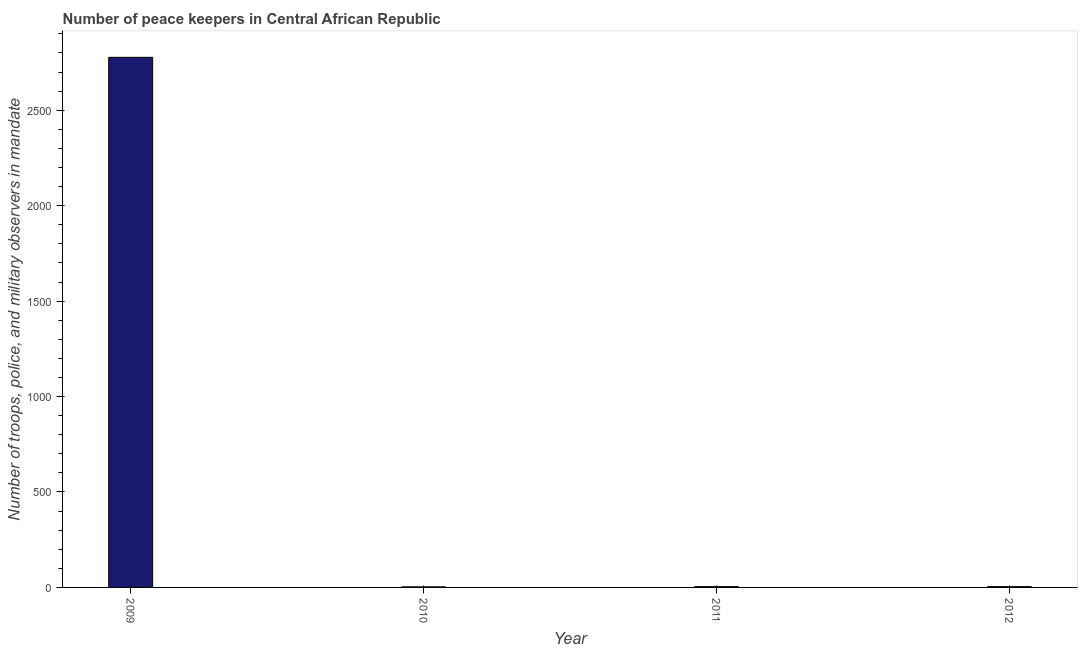Does the graph contain any zero values?
Keep it short and to the point. No. What is the title of the graph?
Offer a very short reply. Number of peace keepers in Central African Republic. What is the label or title of the X-axis?
Your answer should be very brief. Year. What is the label or title of the Y-axis?
Ensure brevity in your answer.  Number of troops, police, and military observers in mandate. What is the number of peace keepers in 2011?
Your response must be concise. 4. Across all years, what is the maximum number of peace keepers?
Offer a very short reply. 2777. In which year was the number of peace keepers minimum?
Provide a succinct answer. 2010. What is the sum of the number of peace keepers?
Provide a succinct answer. 2788. What is the average number of peace keepers per year?
Provide a succinct answer. 697. In how many years, is the number of peace keepers greater than 1600 ?
Your answer should be very brief. 1. What is the ratio of the number of peace keepers in 2010 to that in 2011?
Give a very brief answer. 0.75. Is the number of peace keepers in 2010 less than that in 2012?
Your response must be concise. Yes. Is the difference between the number of peace keepers in 2009 and 2011 greater than the difference between any two years?
Make the answer very short. No. What is the difference between the highest and the second highest number of peace keepers?
Your answer should be compact. 2773. What is the difference between the highest and the lowest number of peace keepers?
Your answer should be very brief. 2774. What is the difference between two consecutive major ticks on the Y-axis?
Your answer should be very brief. 500. Are the values on the major ticks of Y-axis written in scientific E-notation?
Give a very brief answer. No. What is the Number of troops, police, and military observers in mandate of 2009?
Your answer should be very brief. 2777. What is the Number of troops, police, and military observers in mandate of 2012?
Offer a terse response. 4. What is the difference between the Number of troops, police, and military observers in mandate in 2009 and 2010?
Your answer should be very brief. 2774. What is the difference between the Number of troops, police, and military observers in mandate in 2009 and 2011?
Provide a succinct answer. 2773. What is the difference between the Number of troops, police, and military observers in mandate in 2009 and 2012?
Provide a short and direct response. 2773. What is the difference between the Number of troops, police, and military observers in mandate in 2010 and 2011?
Offer a terse response. -1. What is the difference between the Number of troops, police, and military observers in mandate in 2011 and 2012?
Your response must be concise. 0. What is the ratio of the Number of troops, police, and military observers in mandate in 2009 to that in 2010?
Provide a short and direct response. 925.67. What is the ratio of the Number of troops, police, and military observers in mandate in 2009 to that in 2011?
Offer a very short reply. 694.25. What is the ratio of the Number of troops, police, and military observers in mandate in 2009 to that in 2012?
Offer a terse response. 694.25. What is the ratio of the Number of troops, police, and military observers in mandate in 2010 to that in 2012?
Your answer should be very brief. 0.75. What is the ratio of the Number of troops, police, and military observers in mandate in 2011 to that in 2012?
Give a very brief answer. 1. 